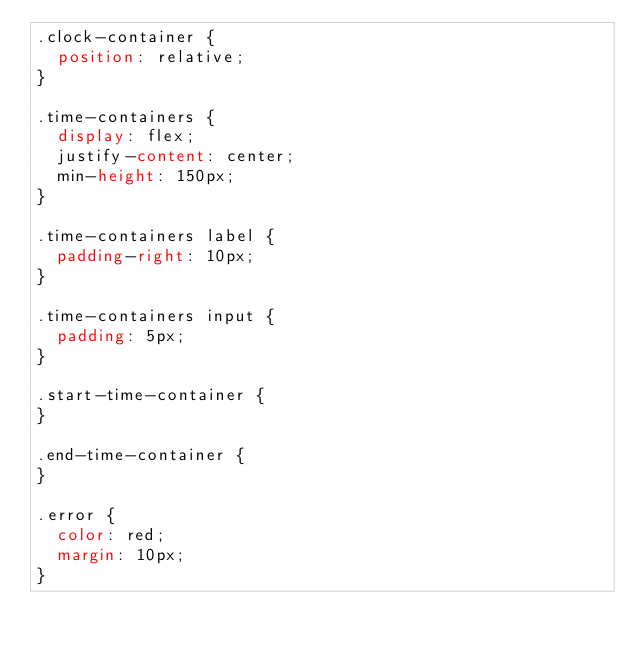<code> <loc_0><loc_0><loc_500><loc_500><_CSS_>.clock-container {
  position: relative;
}

.time-containers {
  display: flex;
  justify-content: center;
  min-height: 150px;
}

.time-containers label {
  padding-right: 10px;
}

.time-containers input {
  padding: 5px;
}

.start-time-container {
}

.end-time-container {
}

.error {
  color: red;
  margin: 10px;
}
</code> 